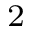<formula> <loc_0><loc_0><loc_500><loc_500>^ { 2 }</formula> 